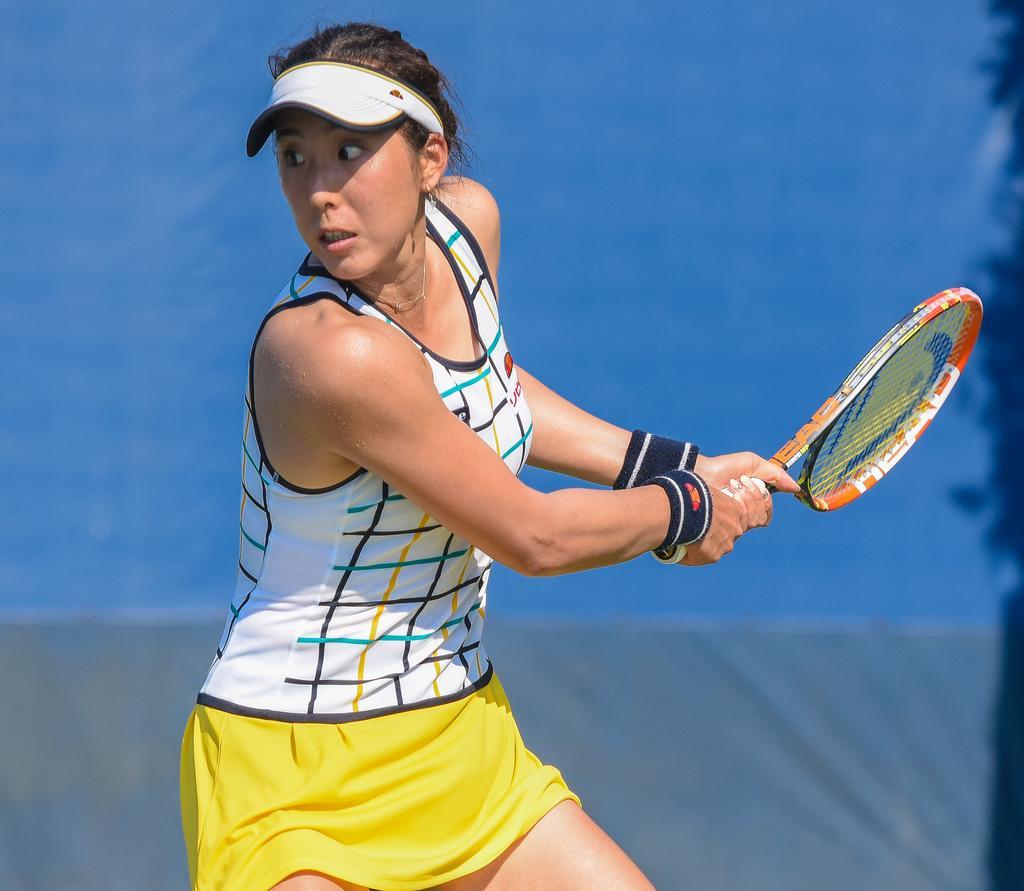Please provide a concise description of this image. In this picture we can see a woman holding a racket with her hand. 